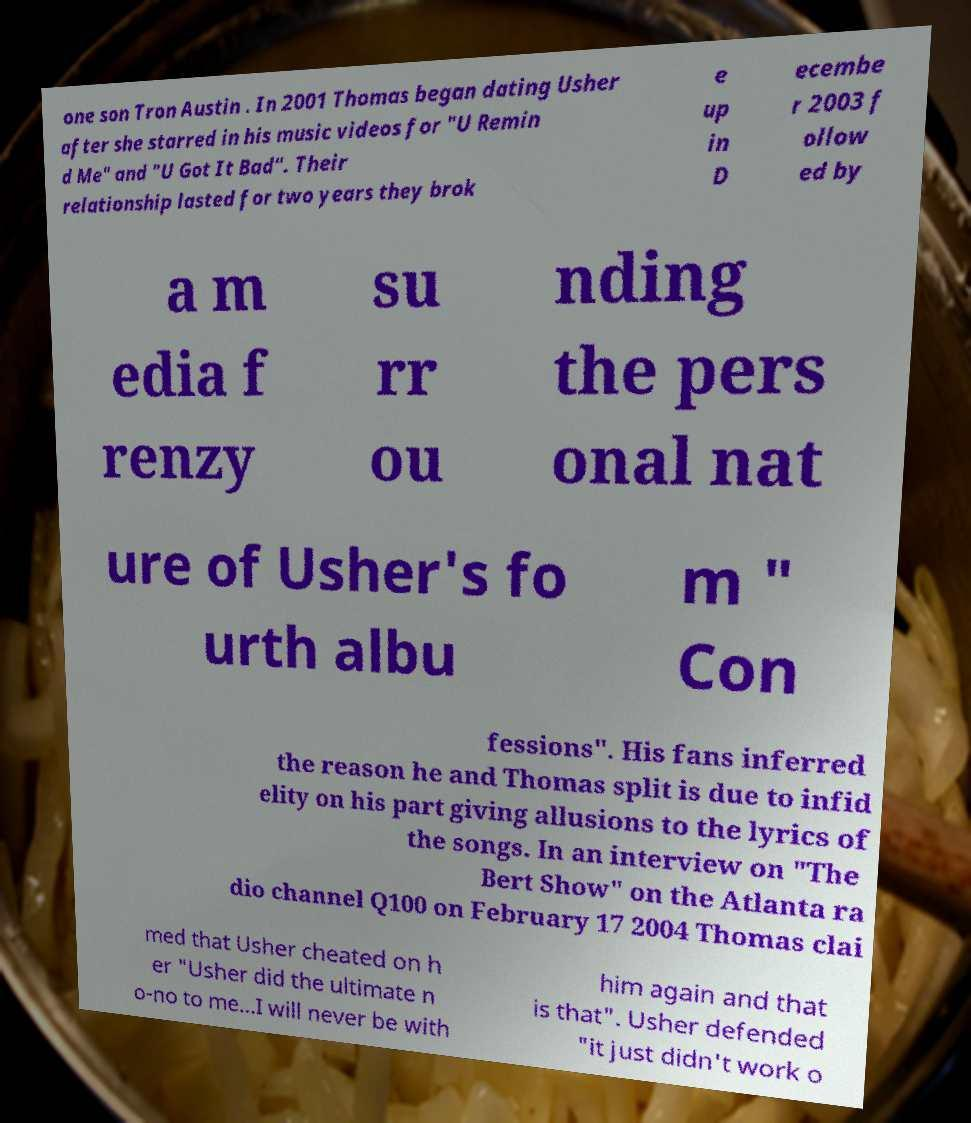Could you assist in decoding the text presented in this image and type it out clearly? one son Tron Austin . In 2001 Thomas began dating Usher after she starred in his music videos for "U Remin d Me" and "U Got It Bad". Their relationship lasted for two years they brok e up in D ecembe r 2003 f ollow ed by a m edia f renzy su rr ou nding the pers onal nat ure of Usher's fo urth albu m " Con fessions". His fans inferred the reason he and Thomas split is due to infid elity on his part giving allusions to the lyrics of the songs. In an interview on "The Bert Show" on the Atlanta ra dio channel Q100 on February 17 2004 Thomas clai med that Usher cheated on h er "Usher did the ultimate n o-no to me...I will never be with him again and that is that". Usher defended "it just didn't work o 